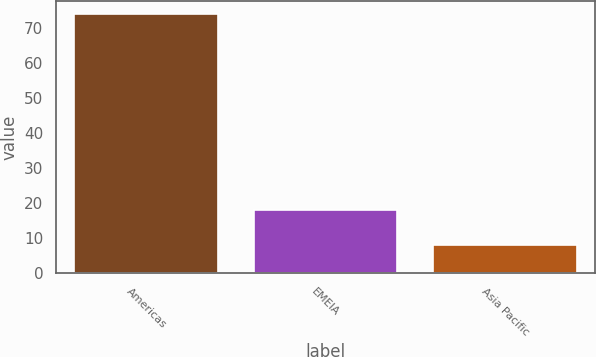Convert chart to OTSL. <chart><loc_0><loc_0><loc_500><loc_500><bar_chart><fcel>Americas<fcel>EMEIA<fcel>Asia Pacific<nl><fcel>74<fcel>18<fcel>8<nl></chart> 